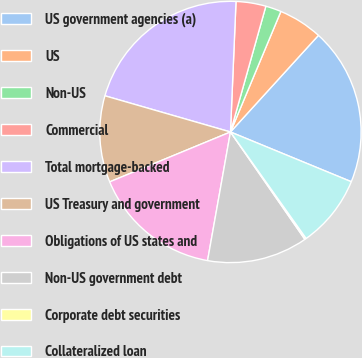Convert chart to OTSL. <chart><loc_0><loc_0><loc_500><loc_500><pie_chart><fcel>US government agencies (a)<fcel>US<fcel>Non-US<fcel>Commercial<fcel>Total mortgage-backed<fcel>US Treasury and government<fcel>Obligations of US states and<fcel>Non-US government debt<fcel>Corporate debt securities<fcel>Collateralized loan<nl><fcel>19.46%<fcel>5.45%<fcel>1.94%<fcel>3.69%<fcel>21.21%<fcel>10.7%<fcel>15.96%<fcel>12.45%<fcel>0.19%<fcel>8.95%<nl></chart> 